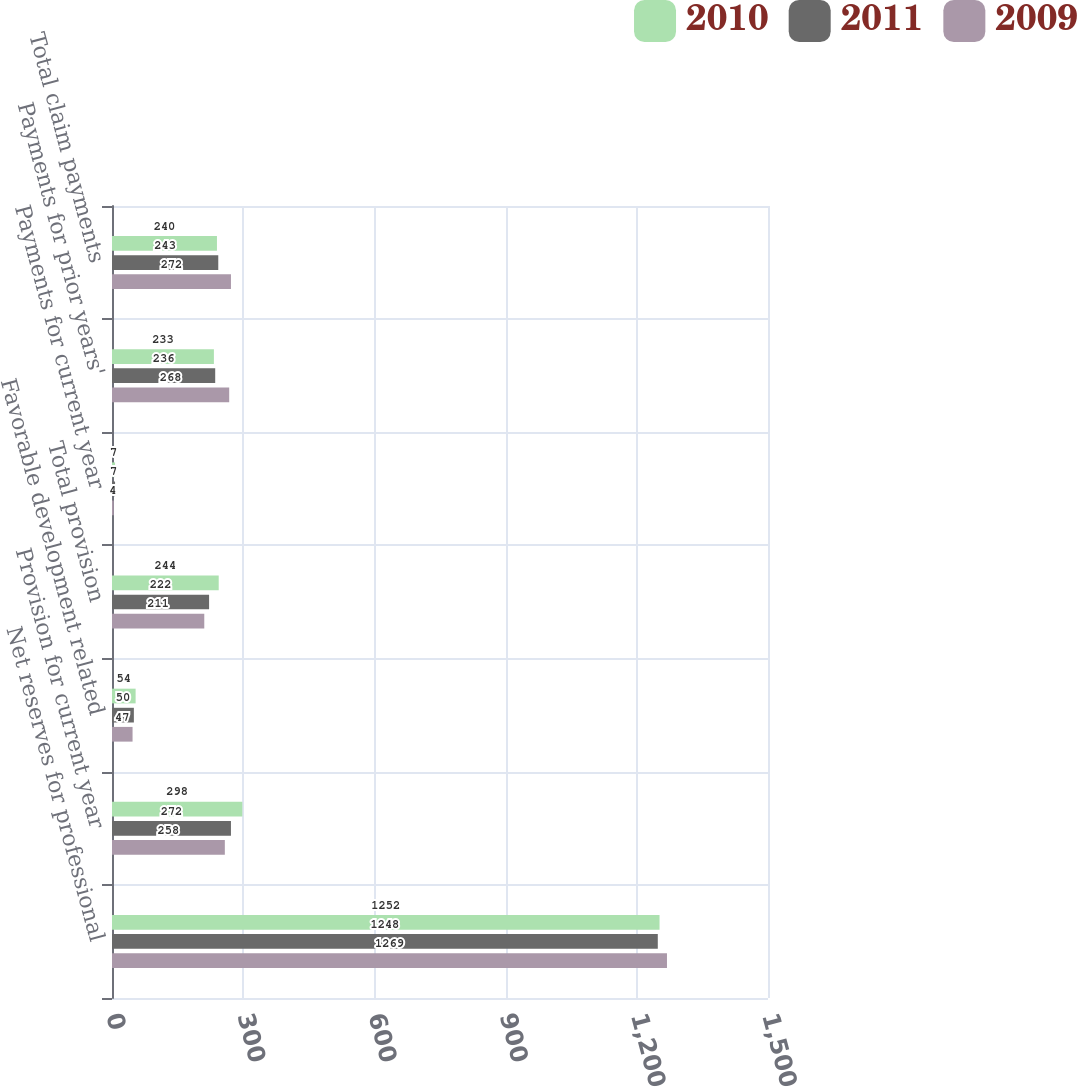Convert chart to OTSL. <chart><loc_0><loc_0><loc_500><loc_500><stacked_bar_chart><ecel><fcel>Net reserves for professional<fcel>Provision for current year<fcel>Favorable development related<fcel>Total provision<fcel>Payments for current year<fcel>Payments for prior years'<fcel>Total claim payments<nl><fcel>2010<fcel>1252<fcel>298<fcel>54<fcel>244<fcel>7<fcel>233<fcel>240<nl><fcel>2011<fcel>1248<fcel>272<fcel>50<fcel>222<fcel>7<fcel>236<fcel>243<nl><fcel>2009<fcel>1269<fcel>258<fcel>47<fcel>211<fcel>4<fcel>268<fcel>272<nl></chart> 